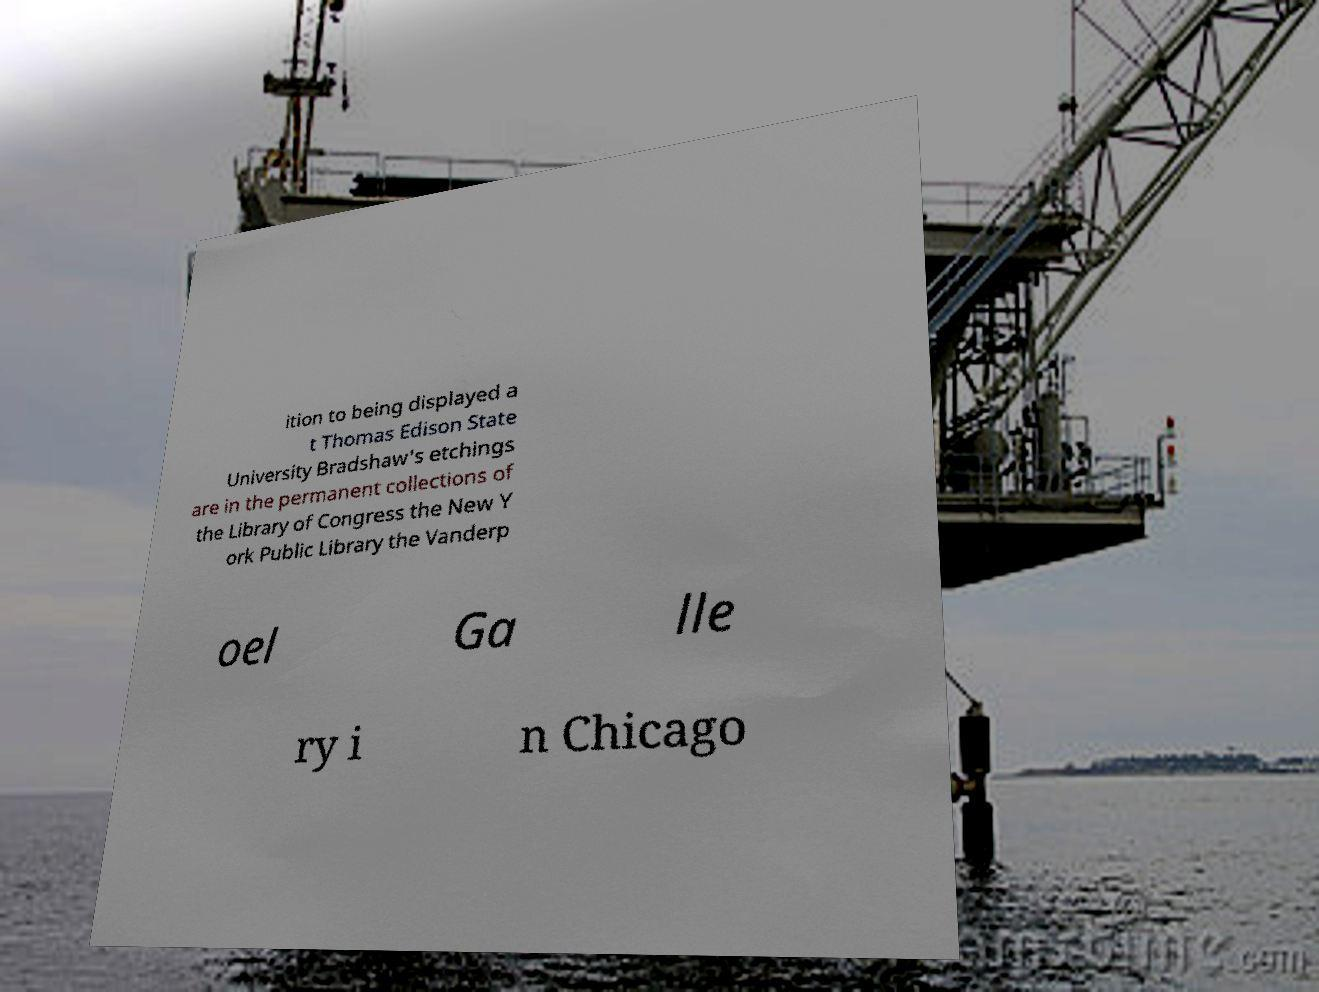Please identify and transcribe the text found in this image. ition to being displayed a t Thomas Edison State University Bradshaw's etchings are in the permanent collections of the Library of Congress the New Y ork Public Library the Vanderp oel Ga lle ry i n Chicago 